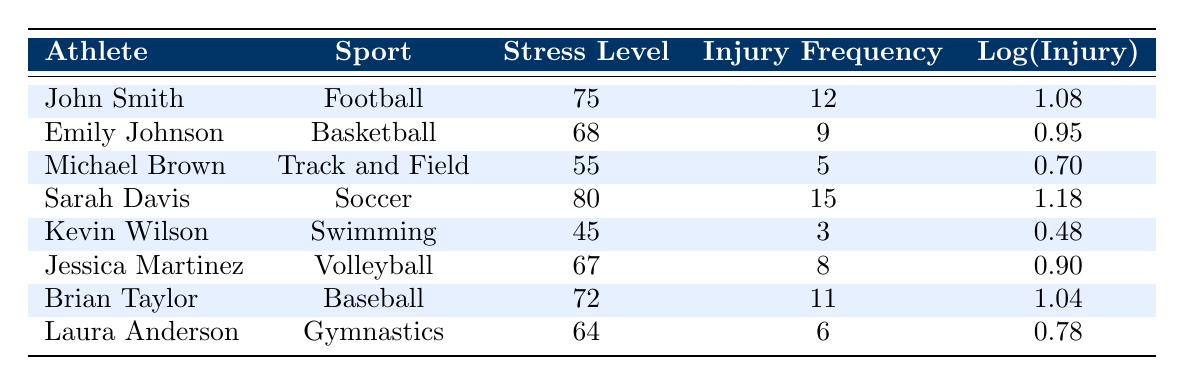What is the stress level of Sarah Davis? From the table, we can directly observe the row corresponding to Sarah Davis, which shows her stress level is listed as 80.
Answer: 80 Which athlete has the highest injury frequency? By comparing the injury frequency values in the table, Sarah Davis has the highest frequency of 15, which is more than any other athlete listed.
Answer: Sarah Davis What is the total injury frequency for athletes with a stress level over 70? The athletes with stress levels over 70 are John Smith (12), Sarah Davis (15), and Brian Taylor (11). Adding these frequencies gives us 12 + 15 + 11 = 38.
Answer: 38 Is Kevin Wilson's injury frequency higher than his stress level? Kevin Wilson has a stress level of 45 and an injury frequency of 3. Since 3 is less than 45, the statement is false.
Answer: No What is the average stress level of all the athletes? To find the average, sum the stress levels of all the athletes: 75 + 68 + 55 + 80 + 45 + 67 + 72 + 64 = 486. Then, divide by the number of athletes (8), giving 486/8 = 60.75.
Answer: 60.75 Which sport has the lowest injury frequency based on the data? The athlete with the lowest injury frequency is Kevin Wilson in Swimming, with a frequency of 3, making Swimming the sport with the lowest injury frequency.
Answer: Swimming Does a higher stress level correlate with a higher injury frequency based on this data? Looking at the table, John Smith has a stress level of 75 and an injury frequency of 12, while Kevin Wilson has a lower stress level of 45 and an even lower injury frequency of 3. This suggests there may not be a direct correlation.
Answer: No What is the difference in injury frequency between the highest and lowest injury frequencies? The highest frequency is Sarah Davis at 15 and the lowest is Kevin Wilson at 3. The difference is 15 - 3 = 12.
Answer: 12 